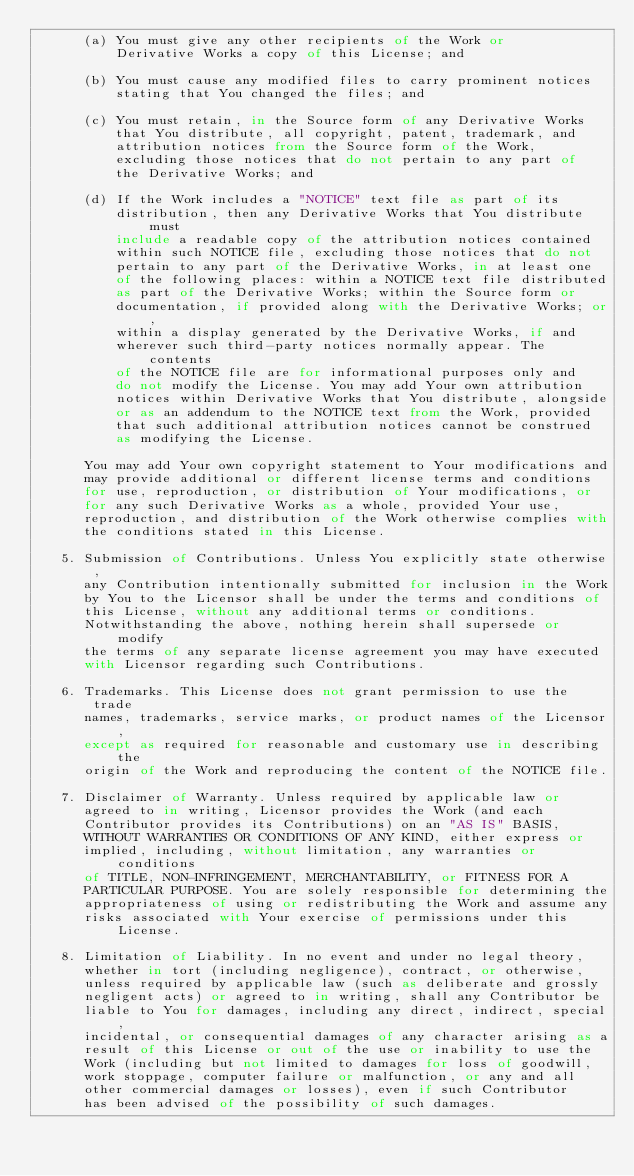Convert code to text. <code><loc_0><loc_0><loc_500><loc_500><_Nim_>      (a) You must give any other recipients of the Work or
          Derivative Works a copy of this License; and

      (b) You must cause any modified files to carry prominent notices
          stating that You changed the files; and

      (c) You must retain, in the Source form of any Derivative Works
          that You distribute, all copyright, patent, trademark, and
          attribution notices from the Source form of the Work,
          excluding those notices that do not pertain to any part of
          the Derivative Works; and

      (d) If the Work includes a "NOTICE" text file as part of its
          distribution, then any Derivative Works that You distribute must
          include a readable copy of the attribution notices contained
          within such NOTICE file, excluding those notices that do not
          pertain to any part of the Derivative Works, in at least one
          of the following places: within a NOTICE text file distributed
          as part of the Derivative Works; within the Source form or
          documentation, if provided along with the Derivative Works; or,
          within a display generated by the Derivative Works, if and
          wherever such third-party notices normally appear. The contents
          of the NOTICE file are for informational purposes only and
          do not modify the License. You may add Your own attribution
          notices within Derivative Works that You distribute, alongside
          or as an addendum to the NOTICE text from the Work, provided
          that such additional attribution notices cannot be construed
          as modifying the License.

      You may add Your own copyright statement to Your modifications and
      may provide additional or different license terms and conditions
      for use, reproduction, or distribution of Your modifications, or
      for any such Derivative Works as a whole, provided Your use,
      reproduction, and distribution of the Work otherwise complies with
      the conditions stated in this License.

   5. Submission of Contributions. Unless You explicitly state otherwise,
      any Contribution intentionally submitted for inclusion in the Work
      by You to the Licensor shall be under the terms and conditions of
      this License, without any additional terms or conditions.
      Notwithstanding the above, nothing herein shall supersede or modify
      the terms of any separate license agreement you may have executed
      with Licensor regarding such Contributions.

   6. Trademarks. This License does not grant permission to use the trade
      names, trademarks, service marks, or product names of the Licensor,
      except as required for reasonable and customary use in describing the
      origin of the Work and reproducing the content of the NOTICE file.

   7. Disclaimer of Warranty. Unless required by applicable law or
      agreed to in writing, Licensor provides the Work (and each
      Contributor provides its Contributions) on an "AS IS" BASIS,
      WITHOUT WARRANTIES OR CONDITIONS OF ANY KIND, either express or
      implied, including, without limitation, any warranties or conditions
      of TITLE, NON-INFRINGEMENT, MERCHANTABILITY, or FITNESS FOR A
      PARTICULAR PURPOSE. You are solely responsible for determining the
      appropriateness of using or redistributing the Work and assume any
      risks associated with Your exercise of permissions under this License.

   8. Limitation of Liability. In no event and under no legal theory,
      whether in tort (including negligence), contract, or otherwise,
      unless required by applicable law (such as deliberate and grossly
      negligent acts) or agreed to in writing, shall any Contributor be
      liable to You for damages, including any direct, indirect, special,
      incidental, or consequential damages of any character arising as a
      result of this License or out of the use or inability to use the
      Work (including but not limited to damages for loss of goodwill,
      work stoppage, computer failure or malfunction, or any and all
      other commercial damages or losses), even if such Contributor
      has been advised of the possibility of such damages.
</code> 